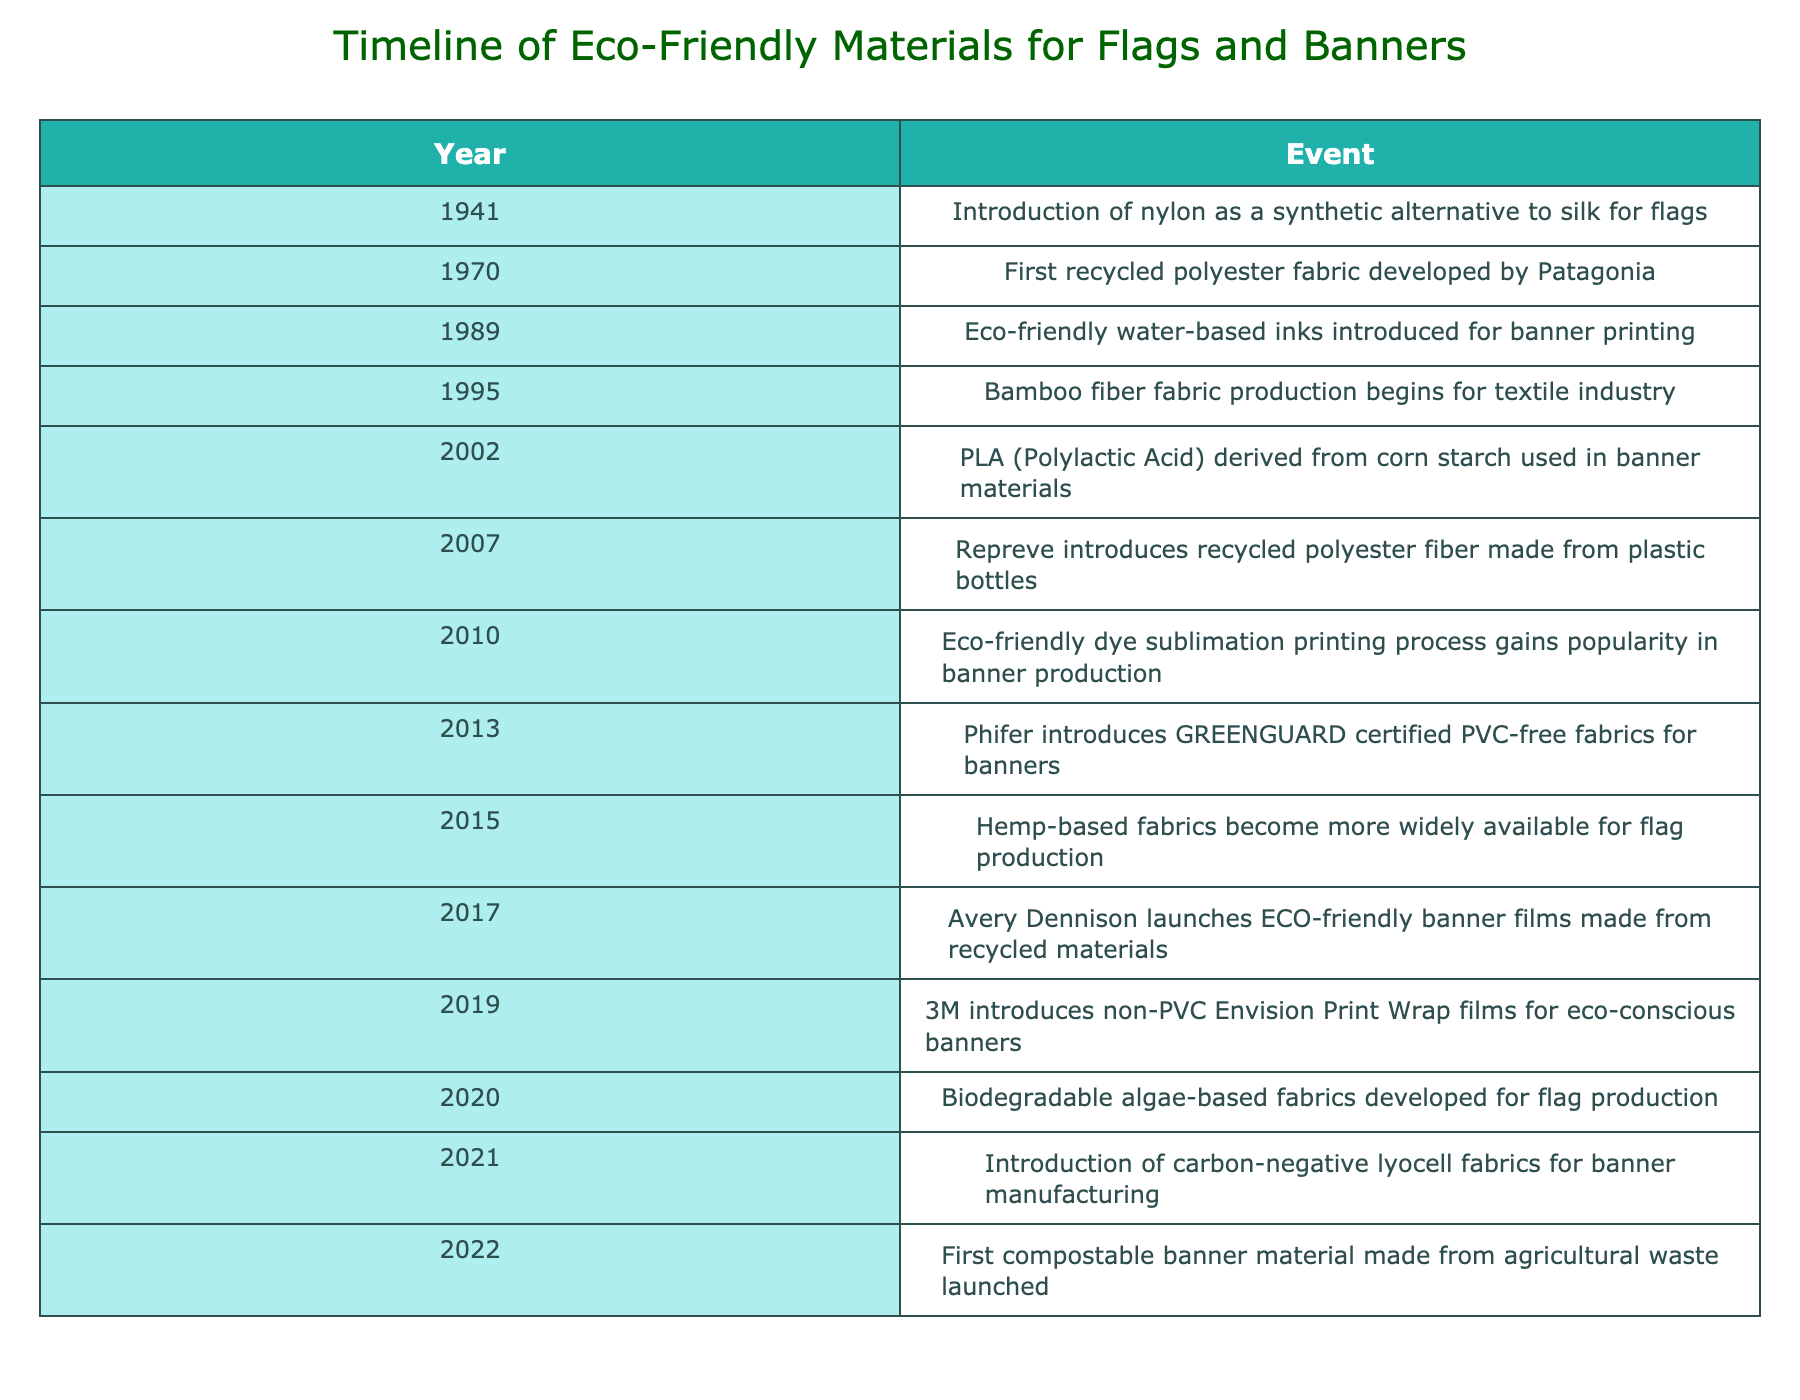What year was the introduction of nylon as a synthetic alternative to silk for flags? The table lists the introduction of nylon as occurring in the year 1941.
Answer: 1941 Which eco-friendly material was first developed by Patagonia? According to the table, the first recycled polyester fabric was developed by Patagonia in 1970.
Answer: Recycled polyester fabric Did bamboo fiber fabric production begin before the introduction of eco-friendly water-based inks? The table shows that bamboo fiber fabric production began in 1995, while eco-friendly water-based inks were introduced in 1989. Since 1989 is earlier than 1995, the statement is false.
Answer: No How many years apart are the introductions of biodegradable algae-based fabrics and carbon-negative lyocell fabrics? Biodegradable algae-based fabrics were introduced in 2020 and carbon-negative lyocell fabrics in 2021. The difference is 2021 - 2020 = 1 year.
Answer: 1 year What event marked the introduction of eco-friendly dye sublimation printing? The table indicates that the eco-friendly dye sublimation printing process gained popularity in 2010.
Answer: 2010 How many materials were introduced after the year 2000? From the table, the years after 2000 include 2002, 2007, 2010, 2013, 2015, 2017, 2019, 2020, 2021, and 2022, totaling 10 materials.
Answer: 10 Was the introduction of hemp-based fabrics before or after the launch of ECO-friendly banner films? According to the data, hemp-based fabrics were widely available in 2015, while ECO-friendly banner films were launched in 2017. Thus, hemp-based fabrics were introduced before the films.
Answer: Before Which event occurred first: the introduction of non-PVC Envision Print Wrap films or the development of biodegradable algae-based fabrics? The introduction of non-PVC Envision Print Wrap films occurred in 2019, while biodegradable algae-based fabrics were developed in 2020. Since 2019 is earlier than 2020, the films were introduced first.
Answer: Non-PVC Envision Print Wrap films How many events in total occurred in the 2010s? The table shows events for the years 2010, 2013, 2015, 2017, and 2019, adding up to 5 events in total during the 2010s.
Answer: 5 events 